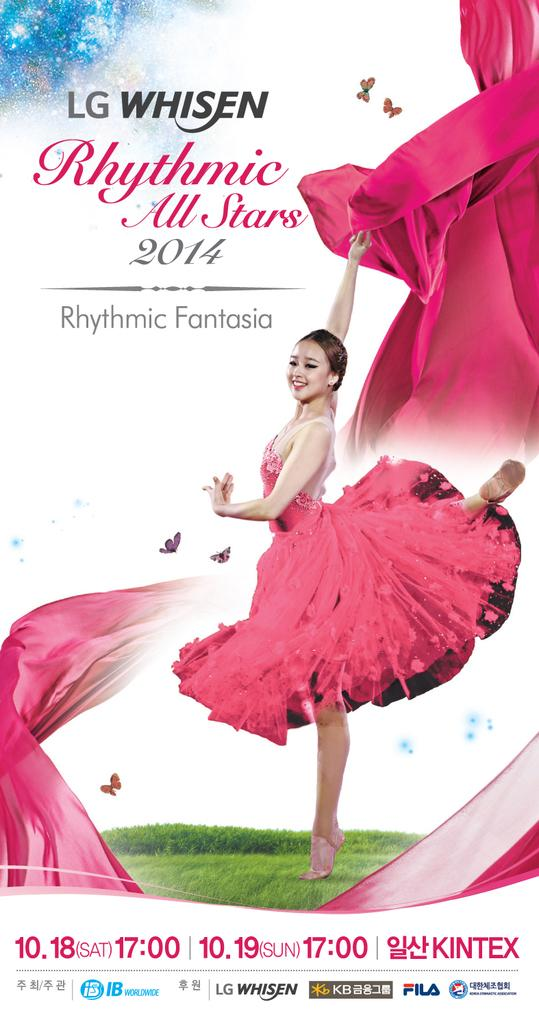What can be observed about the image itself? The image has been edited. What additional information is present on the image? There is text and numbers written on the image. Who is in the image? There is a woman in the image. What is the woman doing in the image? The woman is standing and smiling. What is the woman holding in her hand? The woman is holding a cloth in her hand. What type of suit is the woman wearing in the image? There is no suit visible in the image; the woman is holding a cloth in her hand. Can you tell me how many baskets are present in the image? There are no baskets present in the image; the focus is on the woman and the cloth she is holding. 